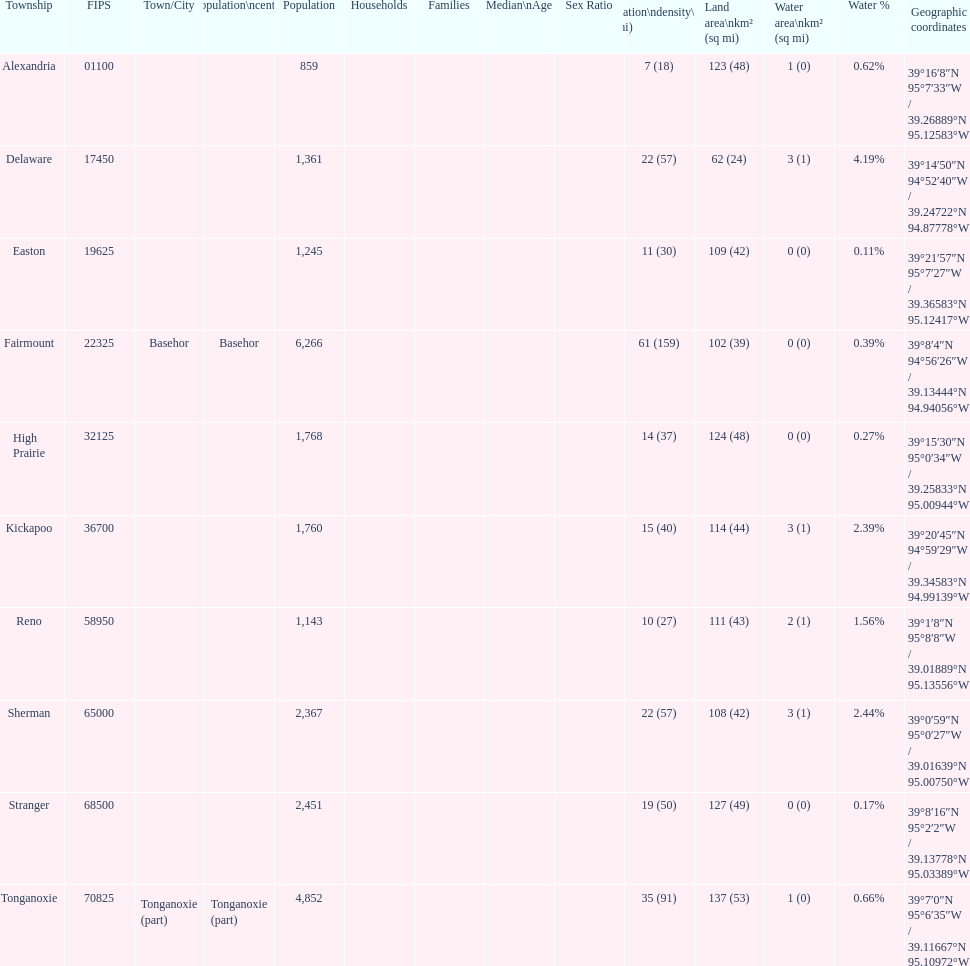Was delaware's land area above or below 45 square miles? Above. 